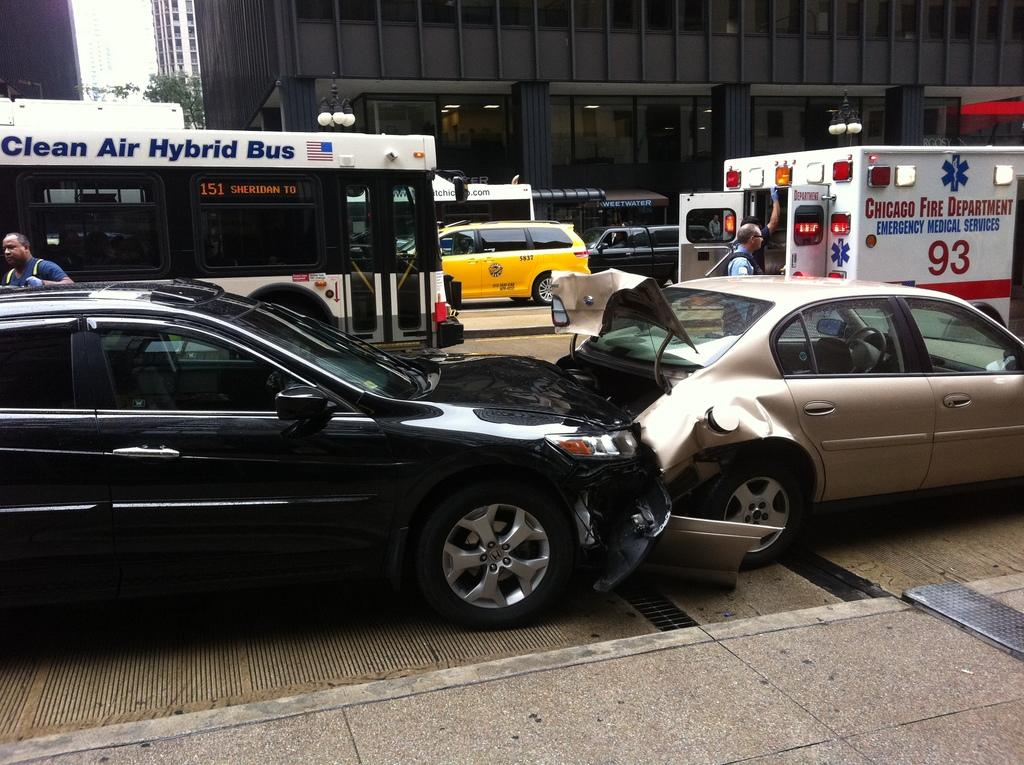<image>
Describe the image concisely. A minor car accident has taken place and the Chicago Fire Department Emergency Medical Services have shown up. 